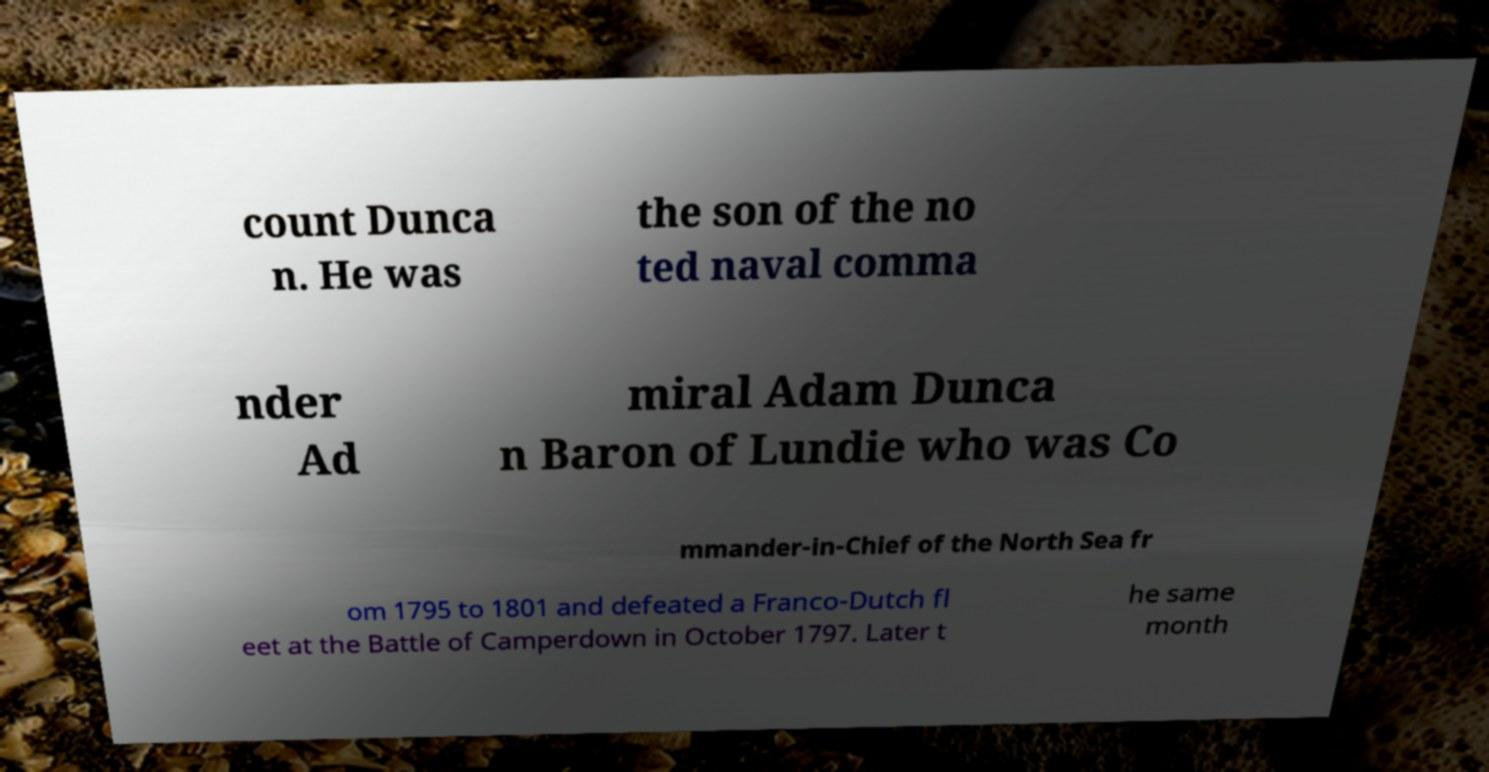There's text embedded in this image that I need extracted. Can you transcribe it verbatim? count Dunca n. He was the son of the no ted naval comma nder Ad miral Adam Dunca n Baron of Lundie who was Co mmander-in-Chief of the North Sea fr om 1795 to 1801 and defeated a Franco-Dutch fl eet at the Battle of Camperdown in October 1797. Later t he same month 